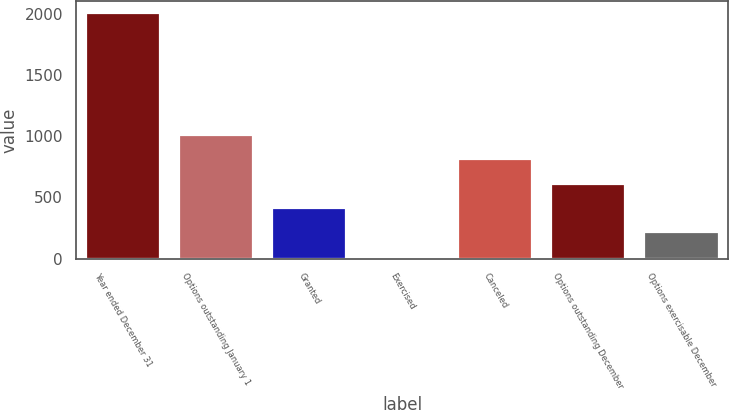<chart> <loc_0><loc_0><loc_500><loc_500><bar_chart><fcel>Year ended December 31<fcel>Options outstanding January 1<fcel>Granted<fcel>Exercised<fcel>Canceled<fcel>Options outstanding December<fcel>Options exercisable December<nl><fcel>2002<fcel>1008.51<fcel>412.41<fcel>15.01<fcel>809.81<fcel>611.11<fcel>213.71<nl></chart> 